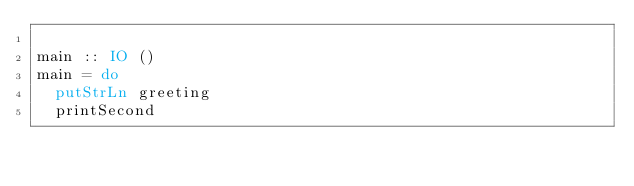<code> <loc_0><loc_0><loc_500><loc_500><_Haskell_>
main :: IO ()
main = do
  putStrLn greeting
  printSecond
</code> 